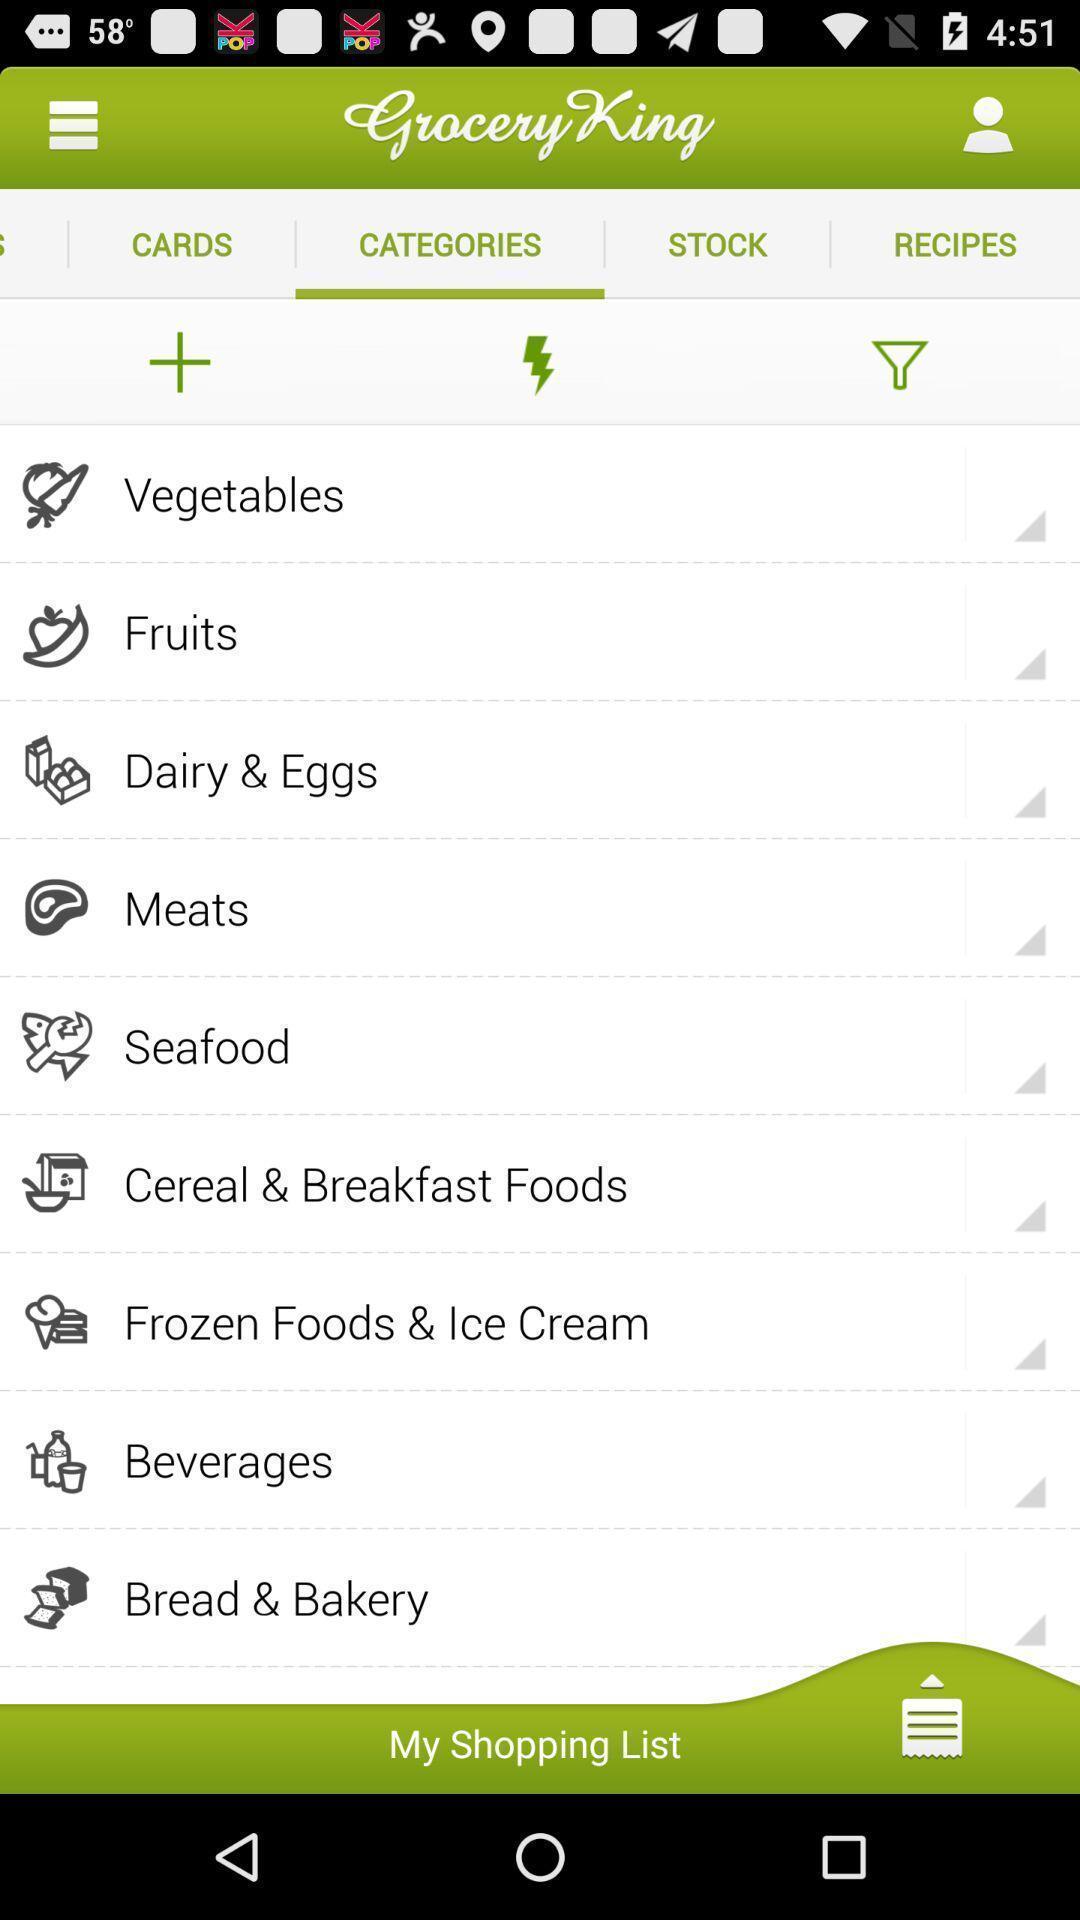Provide a detailed account of this screenshot. Screen shows list of options in a shopping app. 